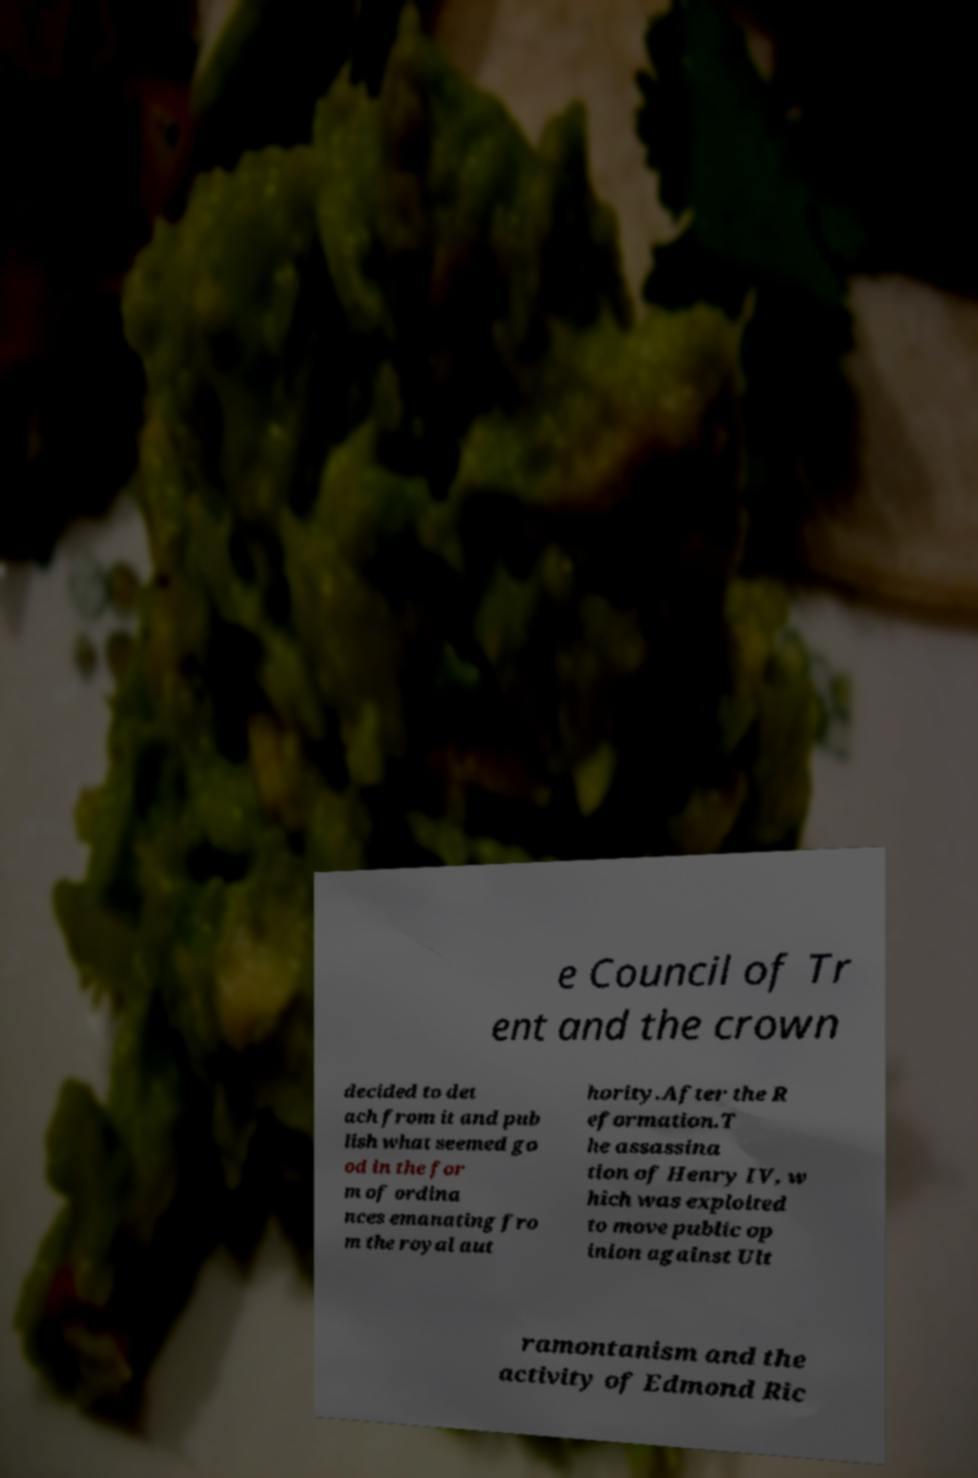For documentation purposes, I need the text within this image transcribed. Could you provide that? e Council of Tr ent and the crown decided to det ach from it and pub lish what seemed go od in the for m of ordina nces emanating fro m the royal aut hority.After the R eformation.T he assassina tion of Henry IV, w hich was exploited to move public op inion against Ult ramontanism and the activity of Edmond Ric 